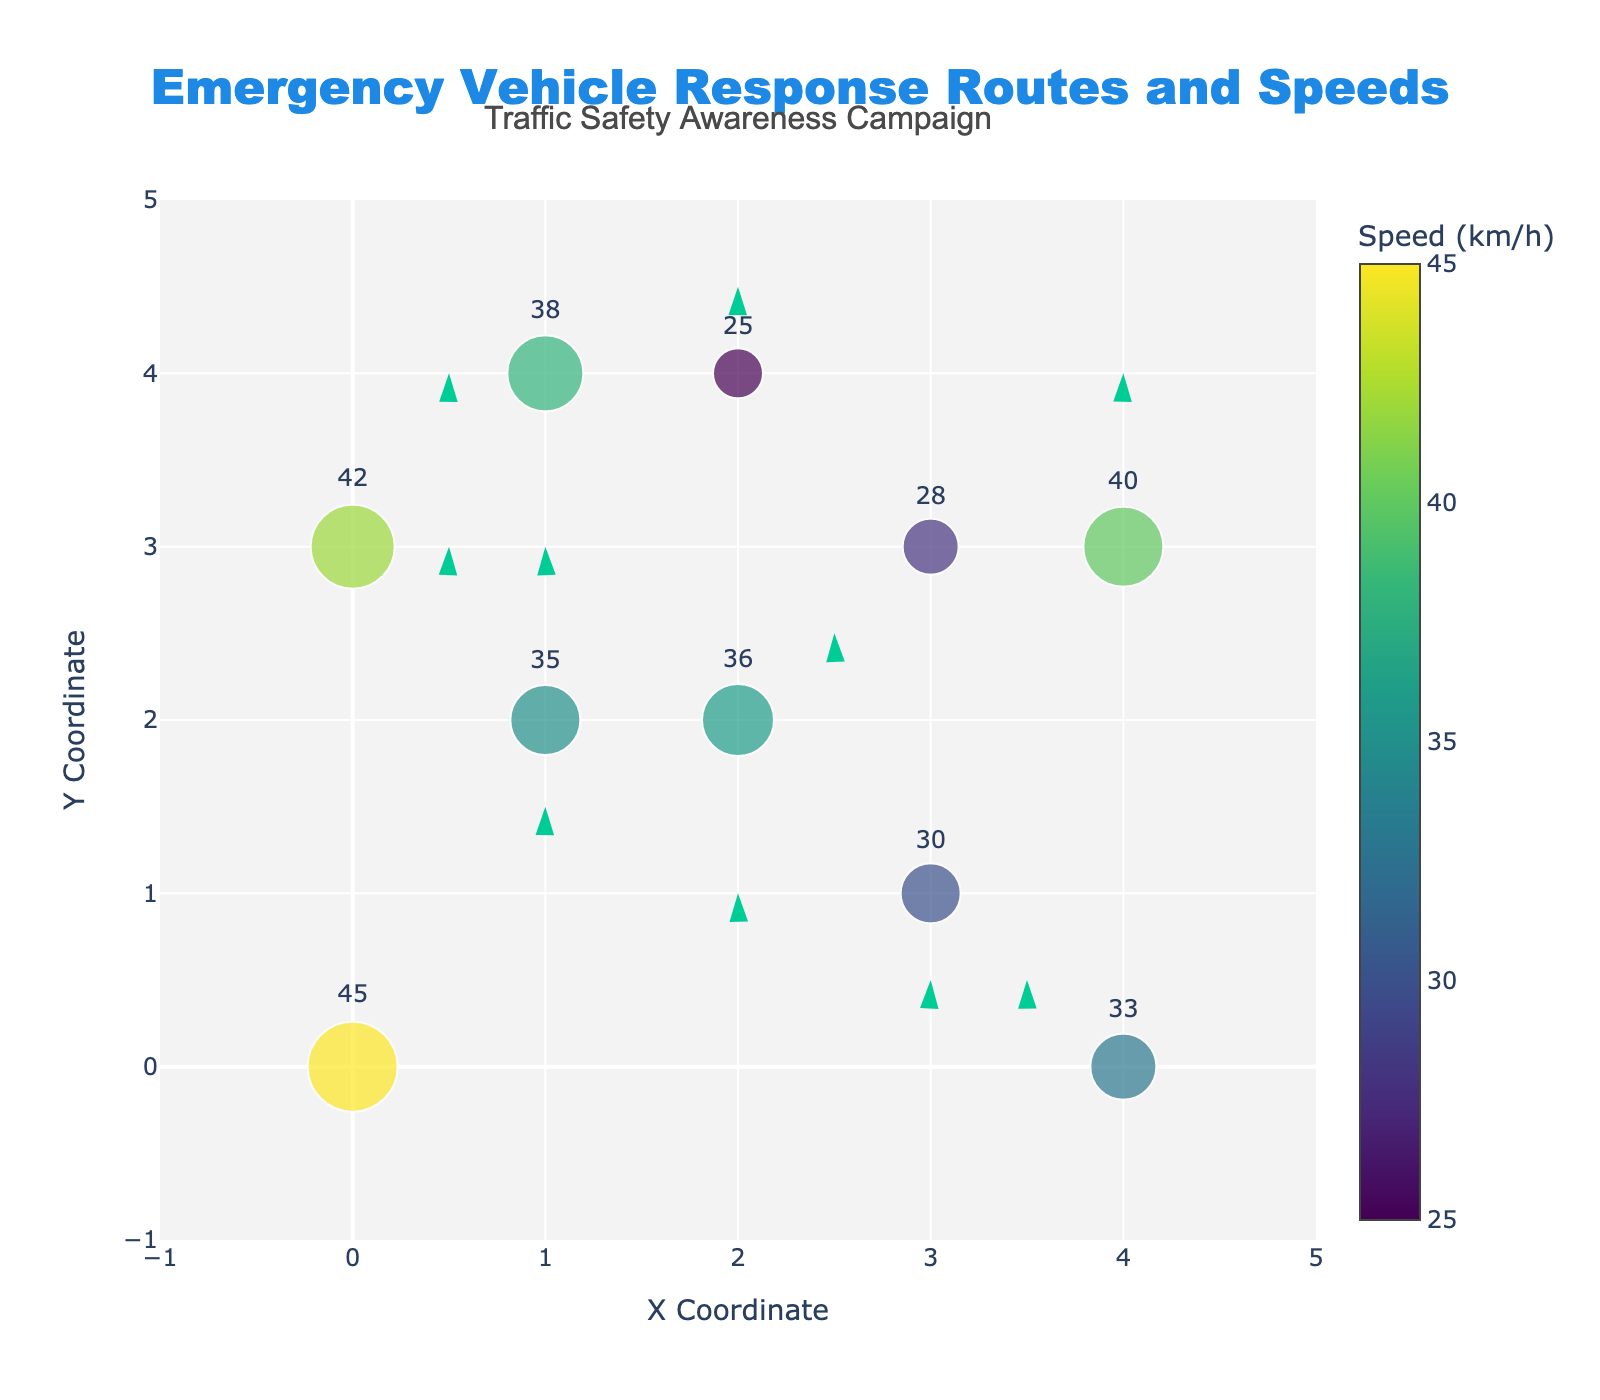How many emergency vehicle routes are plotted? Look at the number of arrows in the figure. Each arrow represents a unique route plotted based on the provided data. Count these arrows to get the total number of routes.
Answer: 10 What does the color of the markers represent? Refer to the color scale and the color legend in the figure. The title of the legend and the range of the color scale will indicate what the colors signify.
Answer: Speed Which route has the highest speed? Identify the marker with the darkest color, which corresponds to the highest value on the color scale. The number inside or beside this marker shows the exact speed.
Answer: 45 km/h Which data point lies at the maximum Y-coordinate, and what is its speed? Check all the Y-coordinates in the figure and identify the highest value. Then, refer to the marker at this Y-coordinate and note the speed associated with it.
Answer: (2, 4) with 25 km/h How many directions point downward? Analyze the direction of each arrow and count those that are pointing downward on the Y-axis, as indicated by negative values of the v component.
Answer: 4 What is the median speed of all the data points? List all the speeds shown in the figure, sort them in ascending order, and find the middle value of this sorted list. If the list has an even number of items, the median is the average of the two middle numbers.
Answer: 35.5 km/h What are the X- and Y-coordinates of the route that moves directly to the right? Identify the arrows with no vertical component (v=0) and a positive horizontal component (u>0). Refer to their starting X- and Y-coordinates.
Answer: (1, 4) What is the average speed of the emergency vehicles? Sum the speeds of all the data points and divide by the number of data points to find the mean speed.
Answer: 35.2 km/h Which route has the largest vector magnitude, and what are its components? Calculate the magnitude of each vector using the formula sqrt(u^2 + v^2) and identify the highest value. Refer to the components (u, v) of this vector.
Answer: (2, 3) with components (2, 3) Where is the annotation for the Traffic Safety Awareness Campaign located on the plot? Look for the text labeled "Traffic Safety Awareness Campaign" and note its relative position within the plot.
Answer: Top center 